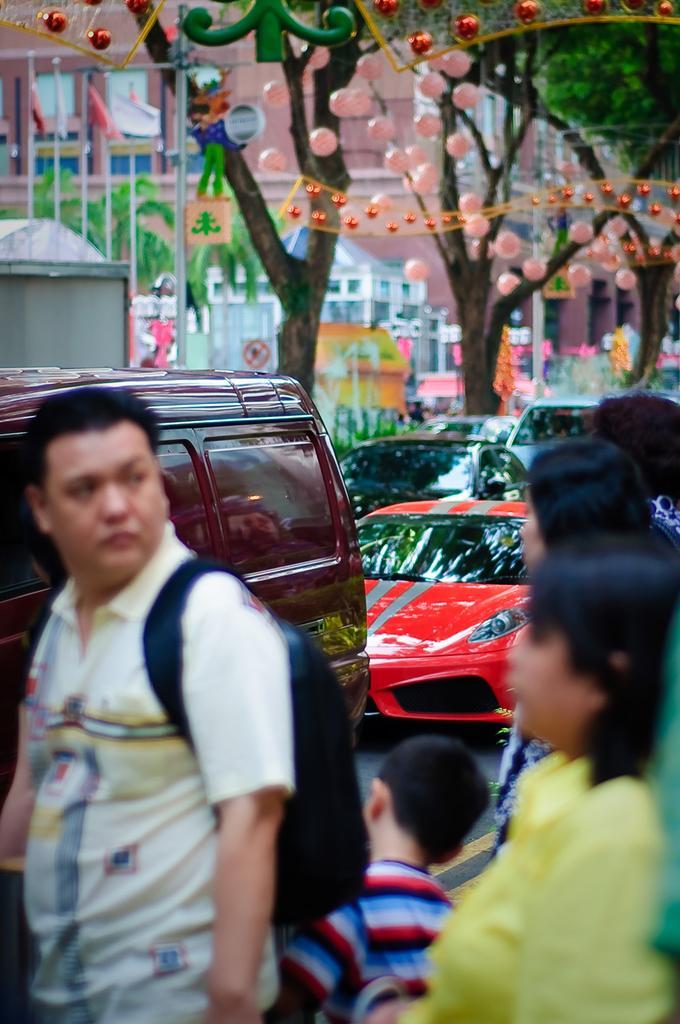Can you describe this image briefly? In the foreground of the picture I can see a few persons. There is a man on the left side and he is carrying a bag on his back. I can see a boy at the bottom of the picture. I can see the vehicles on the road. In the background, I can see the building, trees and flagpoles. 